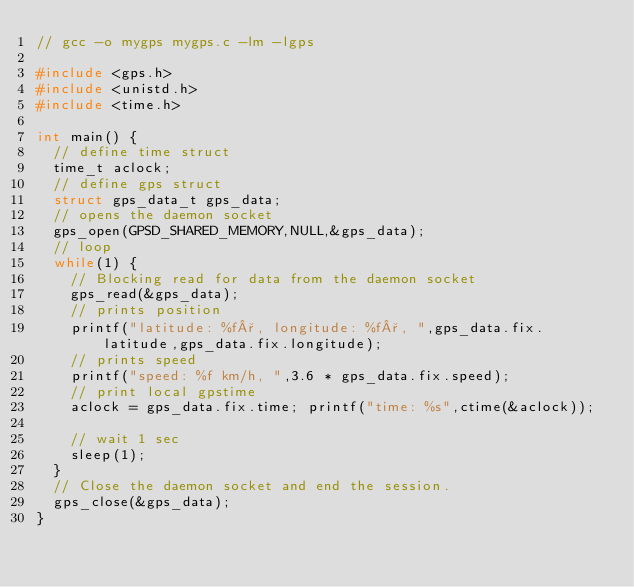Convert code to text. <code><loc_0><loc_0><loc_500><loc_500><_C_>// gcc -o mygps mygps.c -lm -lgps
 
#include <gps.h>
#include <unistd.h>
#include <time.h>
 
int main() {
  // define time struct
  time_t aclock;
  // define gps struct
  struct gps_data_t gps_data;
  // opens the daemon socket
  gps_open(GPSD_SHARED_MEMORY,NULL,&gps_data);
  // loop
  while(1) {
    // Blocking read for data from the daemon socket
    gps_read(&gps_data);
    // prints position
    printf("latitude: %f°, longitude: %f°, ",gps_data.fix.latitude,gps_data.fix.longitude);
    // prints speed
    printf("speed: %f km/h, ",3.6 * gps_data.fix.speed);
    // print local gpstime
    aclock = gps_data.fix.time; printf("time: %s",ctime(&aclock));
 
    // wait 1 sec
    sleep(1);
  }
  // Close the daemon socket and end the session.
  gps_close(&gps_data);
}
</code> 